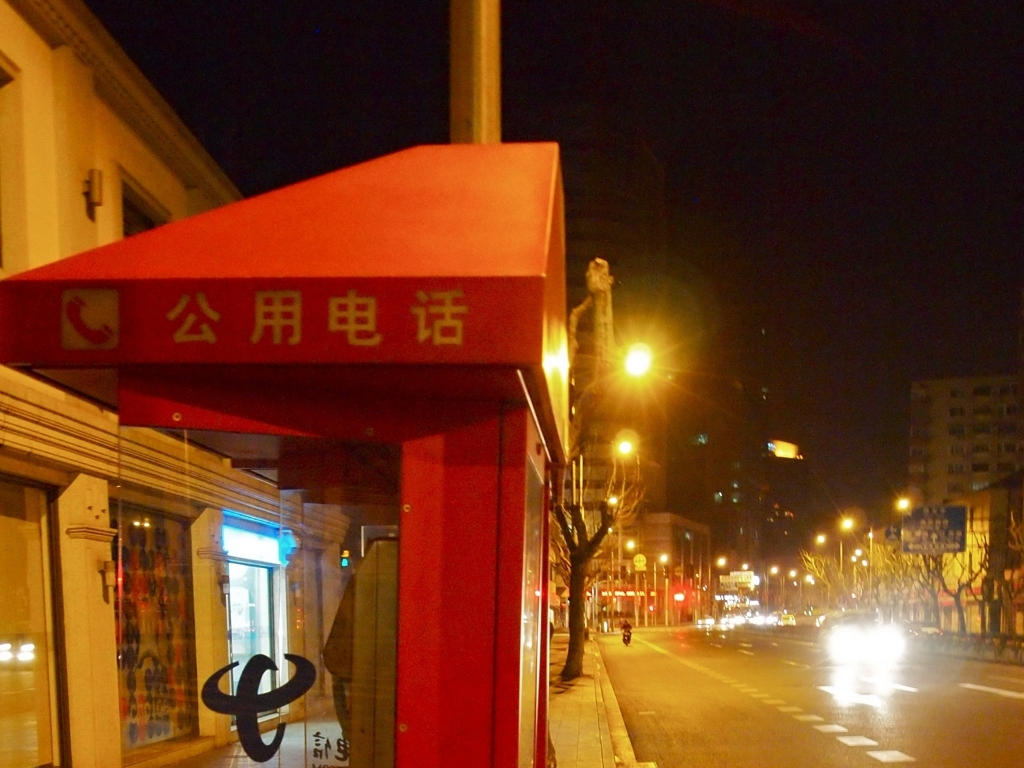What does the overall atmosphere conveyed by the photo suggest about the location? The photo conveys a quiet and calm atmosphere, possibly indicative of a city area during off-peak hours. The mix of subdued ambient lighting and the brightly lit street lamps create a contrast that highlights the stillness of the scene. 